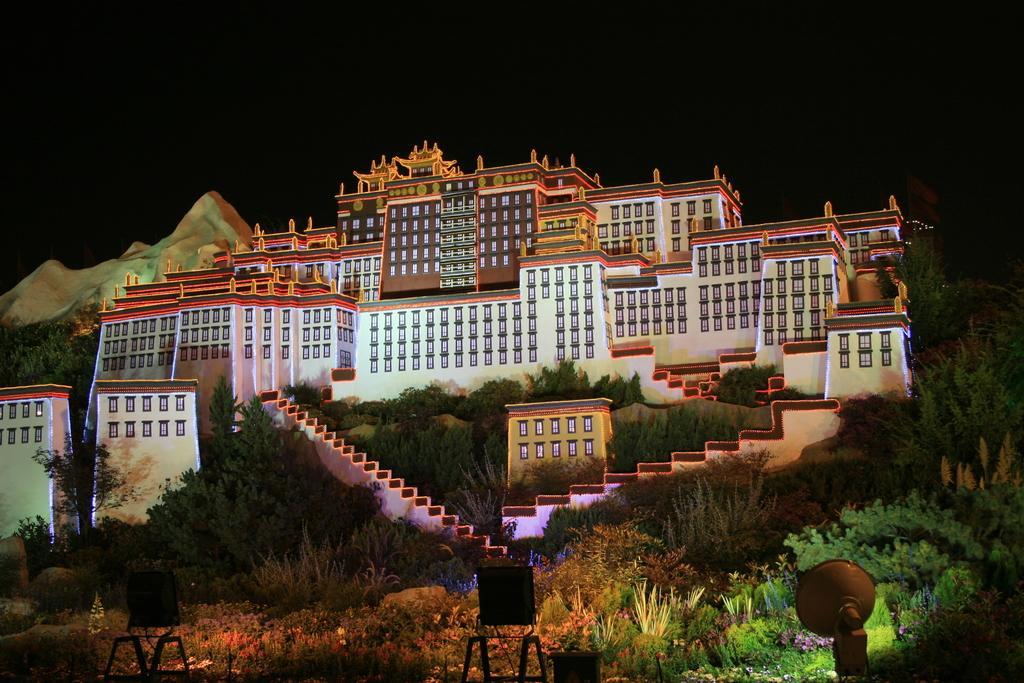How would you summarize this image in a sentence or two? In this image I can see few buildings, windows, trees, stairs, few flowers and lights. Background is in black color. 